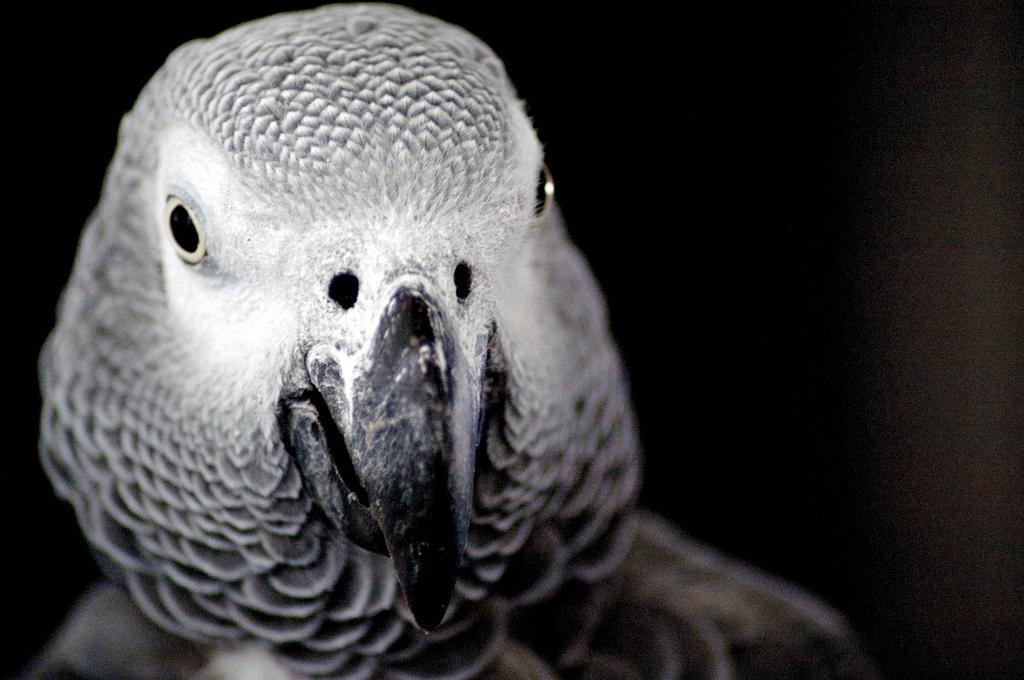What is the main subject of the image? There is a bird in the center of the image. Can you describe the bird in the image? The bird is the main focus of the image, but no specific details about its appearance are provided. What is the bird's position in the image? The bird is located in the center of the image. What type of apparel is the bird wearing in the image? There is no mention of the bird wearing any apparel in the image. What vegetable is the bird holding in the image? There is no vegetable present in the image; the bird is the only subject mentioned. 